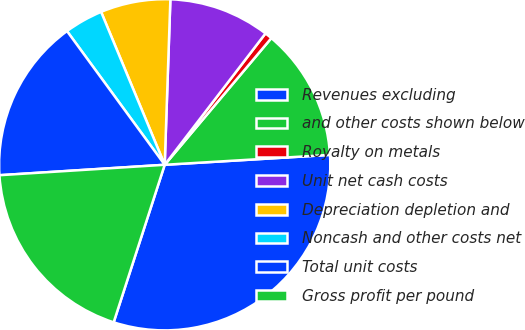<chart> <loc_0><loc_0><loc_500><loc_500><pie_chart><fcel>Revenues excluding<fcel>and other costs shown below<fcel>Royalty on metals<fcel>Unit net cash costs<fcel>Depreciation depletion and<fcel>Noncash and other costs net<fcel>Total unit costs<fcel>Gross profit per pound<nl><fcel>30.94%<fcel>12.91%<fcel>0.72%<fcel>9.87%<fcel>6.82%<fcel>3.77%<fcel>15.96%<fcel>19.01%<nl></chart> 